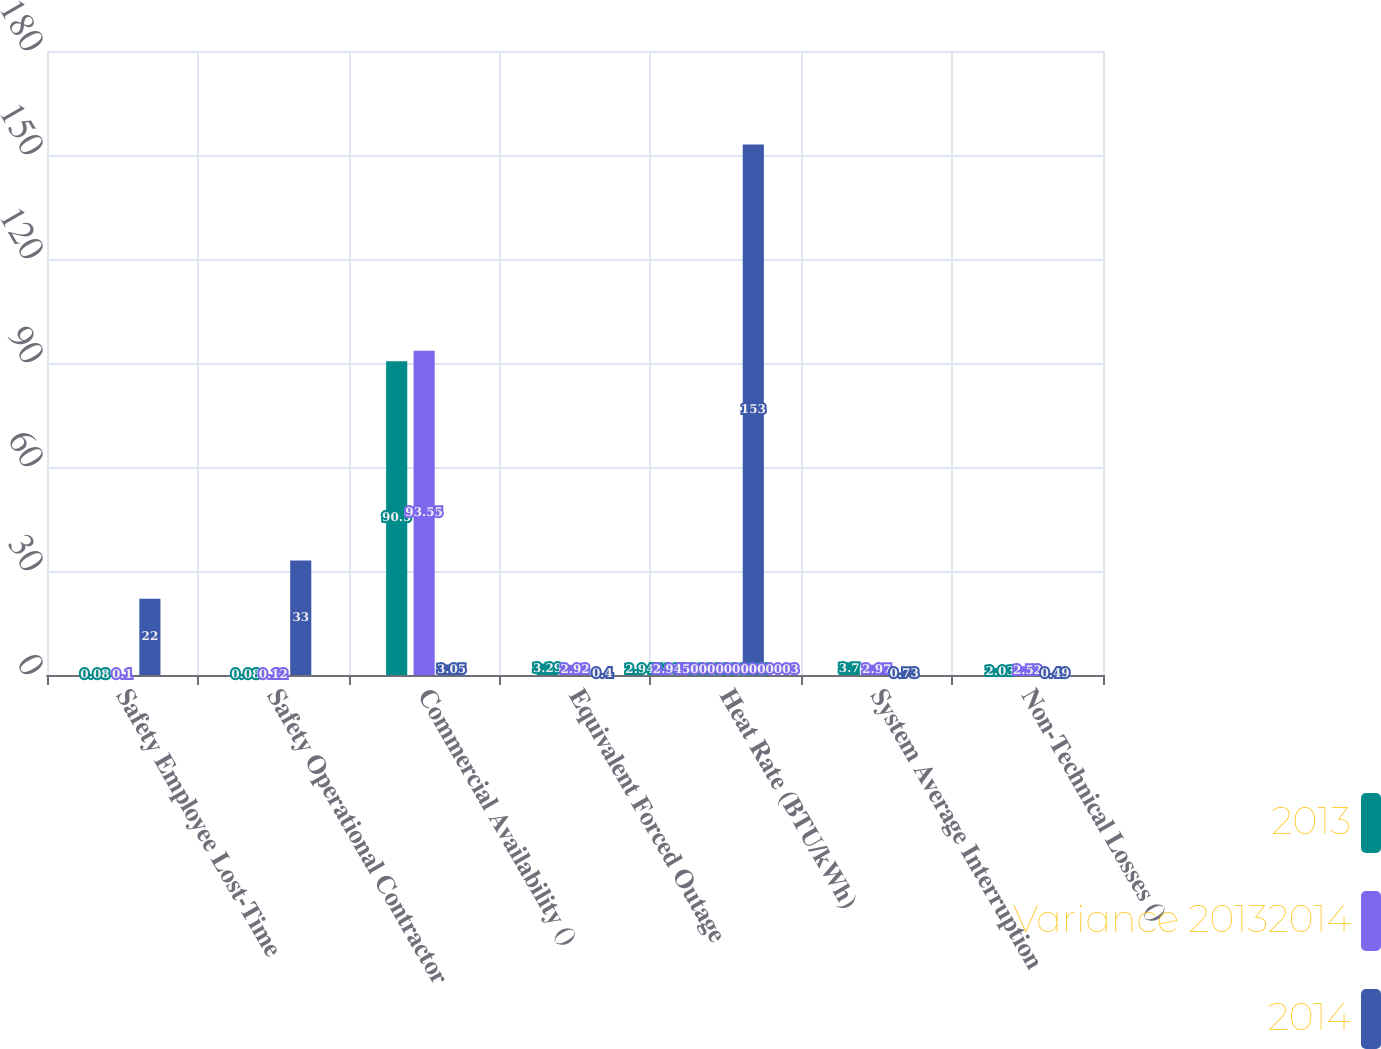Convert chart. <chart><loc_0><loc_0><loc_500><loc_500><stacked_bar_chart><ecel><fcel>Safety Employee Lost-Time<fcel>Safety Operational Contractor<fcel>Commercial Availability ()<fcel>Equivalent Forced Outage<fcel>Heat Rate (BTU/kWh)<fcel>System Average Interruption<fcel>Non-Technical Losses ()<nl><fcel>2013<fcel>0.08<fcel>0.08<fcel>90.5<fcel>3.29<fcel>2.945<fcel>3.7<fcel>2.03<nl><fcel>Variance 20132014<fcel>0.1<fcel>0.12<fcel>93.55<fcel>2.92<fcel>2.945<fcel>2.97<fcel>2.52<nl><fcel>2014<fcel>22<fcel>33<fcel>3.05<fcel>0.4<fcel>153<fcel>0.73<fcel>0.49<nl></chart> 